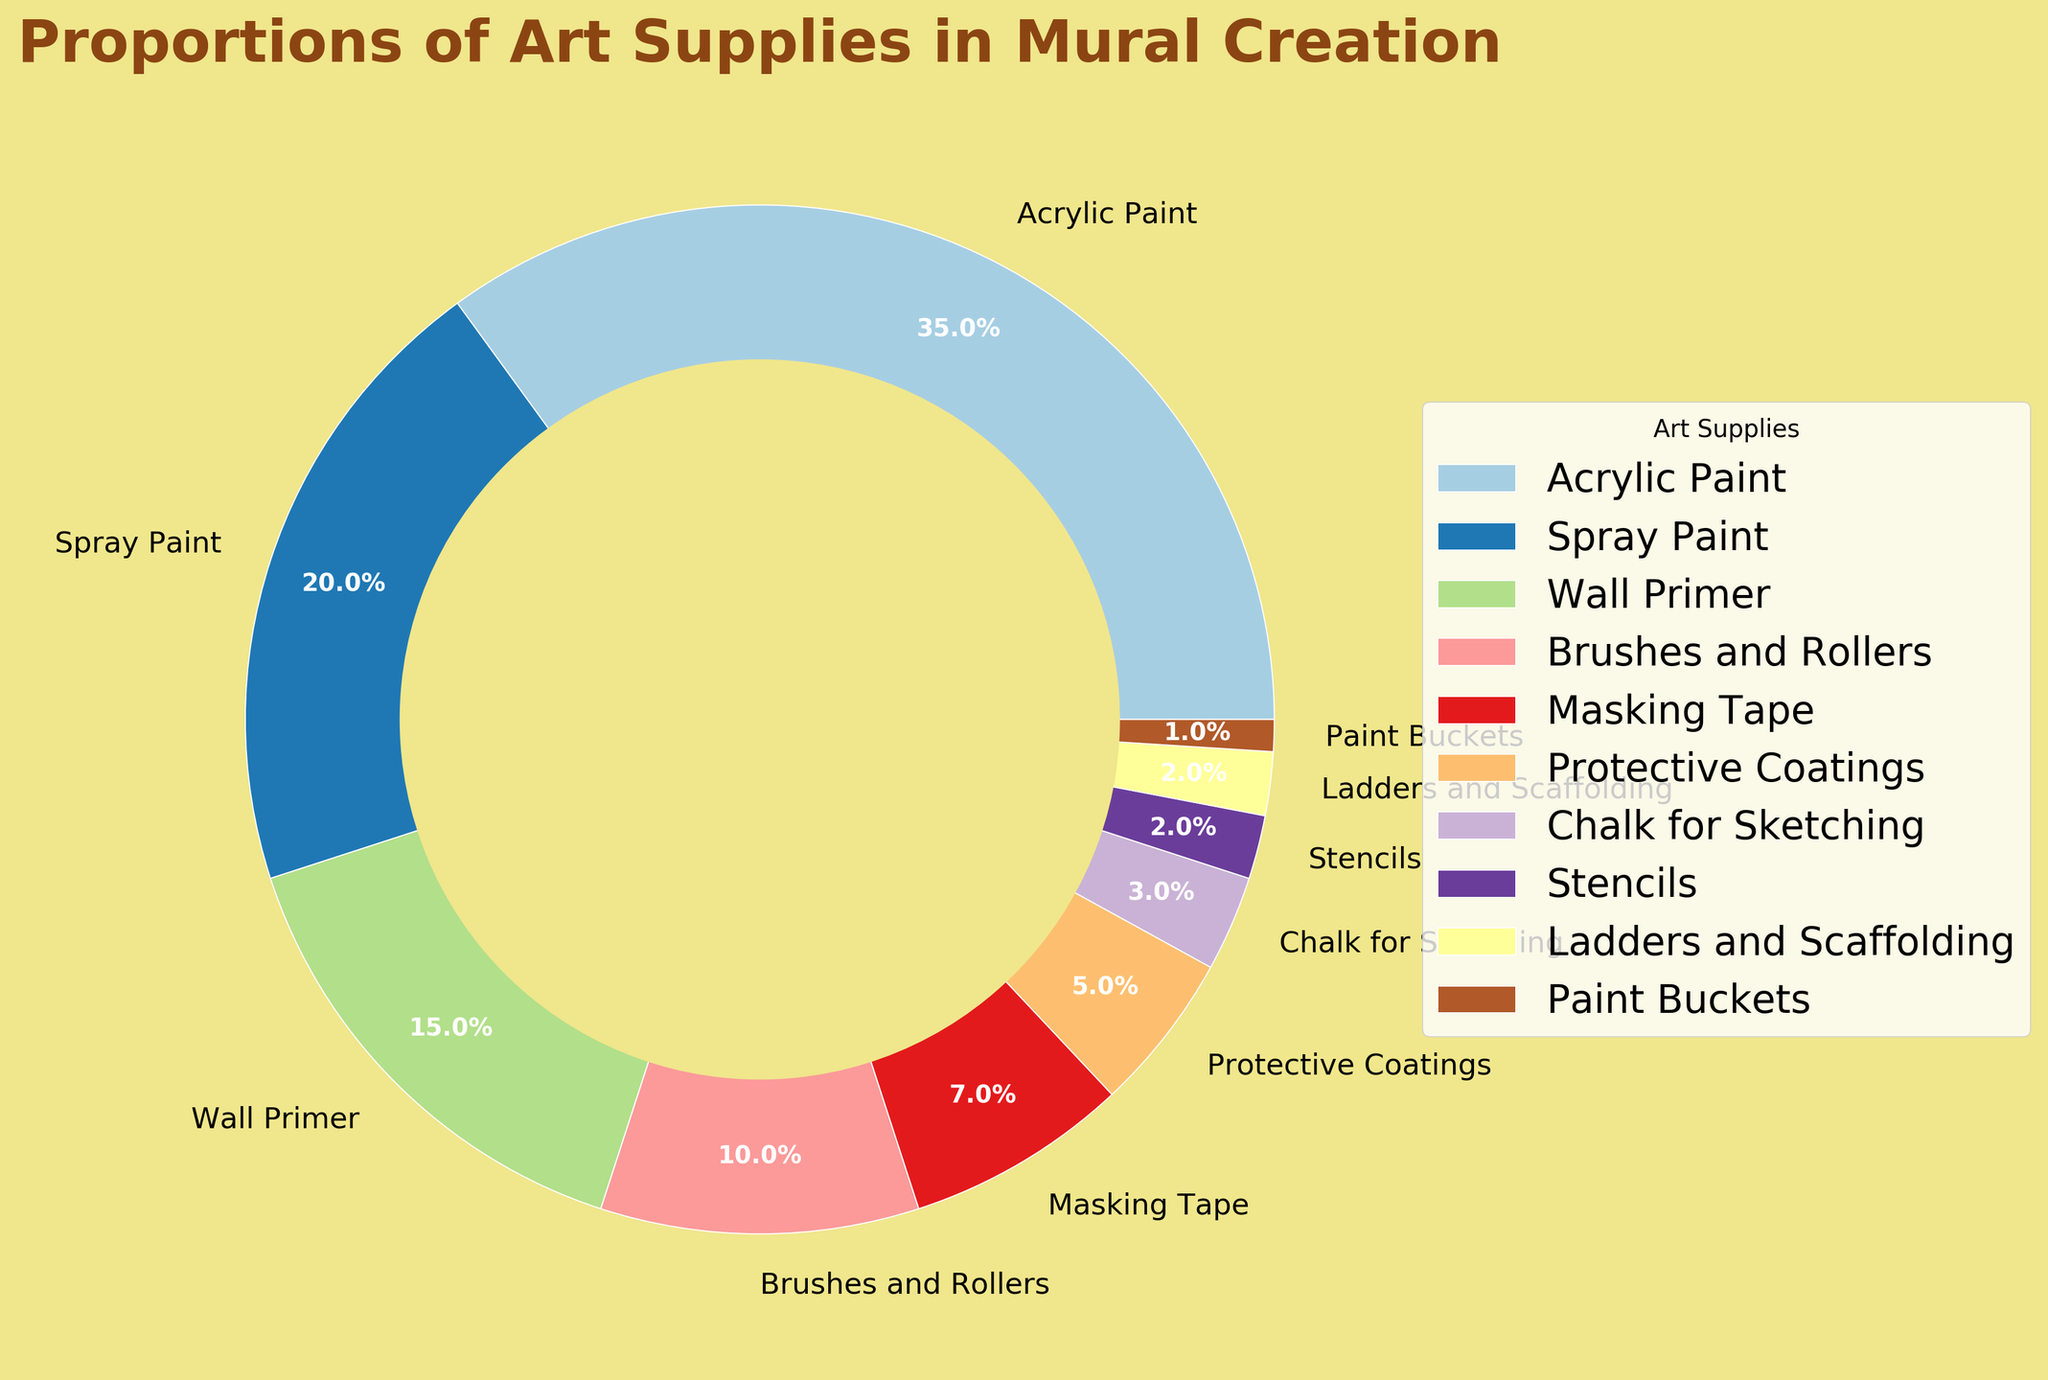What is the largest proportion of art supplies used in mural creation? The largest proportion is indicated by the segment with the highest percentage in the pie chart, which is Acrylic Paint at 35%.
Answer: Acrylic Paint (35%) What are the proportions of both Spray Paint and Wall Primer combined? Add the percentages of Spray Paint (20%) and Wall Primer (15%) together: 20% + 15% = 35%.
Answer: 35% Which art supply has the smallest proportion in the mural creation? The smallest proportion is represented by the smallest segment, which belongs to Paint Buckets at 1%.
Answer: Paint Buckets (1%) How does the proportion of Brushes and Rollers compare to Masking Tape? Compare their percentages: Brushes and Rollers have 10%, and Masking Tape has 7%. 10% is greater than 7%.
Answer: Greater What is the total proportion of the supplies with less than 5% each? Sum the percentages of Chalk for Sketching (3%), Stencils (2%), Ladders and Scaffolding (2%), and Paint Buckets (1%): 3% + 2% + 2% + 1% = 8%.
Answer: 8% Which supply segment is visually represented with the brightest color? Without particular color coding details and only knowing the segment names, identify the colors in the pie chart and find the supply with the visually brightest appearance. This requires visual inspection.
Answer: Depends on chart visual Is the proportion of Wall Primer more than double that of Brushes and Rollers? Wall Primer is 15%, and Brushes and Rollers are 10%. Double of Brushes and Rollers would be 10% * 2 = 20%. 15% is not more than 20%.
Answer: No By how much does the proportion of Acrylic Paint exceed that of Protective Coatings? Subtract the percentage of Protective Coatings (5%) from Acrylic Paint (35%): 35% - 5% = 30%.
Answer: 30% What is the average percentage of Spray Paint, Wall Primer, and Protective Coatings? Sum the percentages of Spray Paint (20%), Wall Primer (15%), and Protective Coatings (5%) and divide by 3: (20% + 15% + 5%) / 3 = 40% / 3 ≈ 13.33%.
Answer: ~13.33% Which supply has exactly half the proportion of Brushes and Rollers? Brushes and Rollers have 10%, and half of 10% is 5%. The supply with 5% is Protective Coatings.
Answer: Protective Coatings 